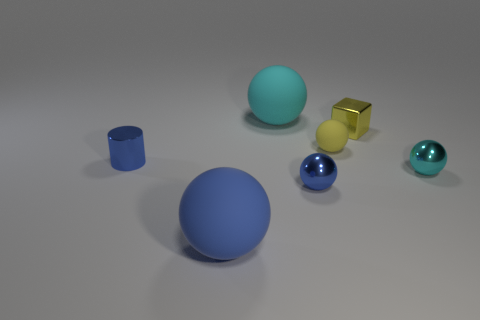What is the size of the matte sphere that is both behind the tiny cyan metallic object and in front of the cyan matte ball?
Your response must be concise. Small. Are there more blue cylinders in front of the yellow metallic object than big spheres that are in front of the tiny cyan metal sphere?
Offer a terse response. No. There is a tiny yellow shiny object; does it have the same shape as the tiny blue metallic thing behind the small cyan thing?
Ensure brevity in your answer.  No. How many other things are there of the same shape as the small yellow metallic thing?
Provide a succinct answer. 0. What color is the matte thing that is both in front of the yellow metallic block and behind the blue rubber sphere?
Your answer should be compact. Yellow. The tiny metallic cube has what color?
Your answer should be compact. Yellow. Do the small yellow cube and the cyan sphere in front of the yellow sphere have the same material?
Give a very brief answer. Yes. There is a tiny object that is the same material as the large blue sphere; what shape is it?
Provide a short and direct response. Sphere. The matte object that is the same size as the metallic cube is what color?
Keep it short and to the point. Yellow. There is a metallic thing to the left of the blue matte thing; is its size the same as the metallic block?
Your answer should be very brief. Yes. 